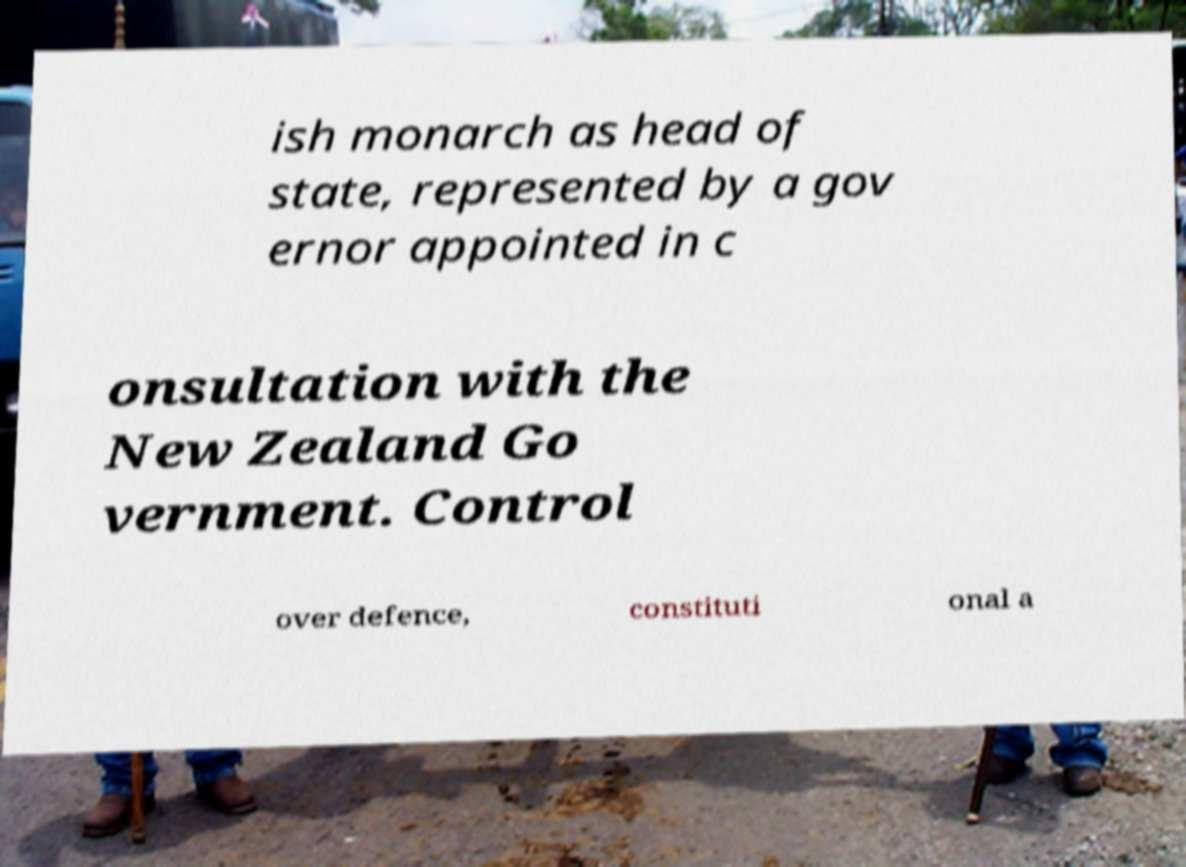Can you accurately transcribe the text from the provided image for me? ish monarch as head of state, represented by a gov ernor appointed in c onsultation with the New Zealand Go vernment. Control over defence, constituti onal a 